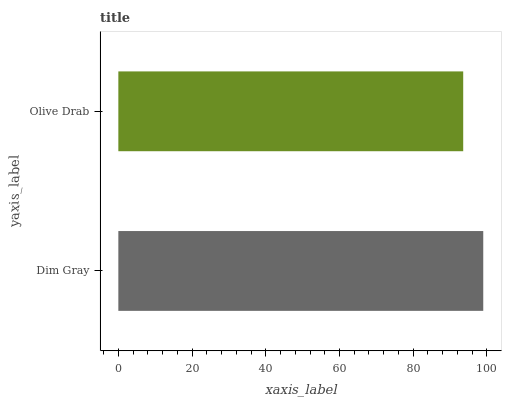Is Olive Drab the minimum?
Answer yes or no. Yes. Is Dim Gray the maximum?
Answer yes or no. Yes. Is Olive Drab the maximum?
Answer yes or no. No. Is Dim Gray greater than Olive Drab?
Answer yes or no. Yes. Is Olive Drab less than Dim Gray?
Answer yes or no. Yes. Is Olive Drab greater than Dim Gray?
Answer yes or no. No. Is Dim Gray less than Olive Drab?
Answer yes or no. No. Is Dim Gray the high median?
Answer yes or no. Yes. Is Olive Drab the low median?
Answer yes or no. Yes. Is Olive Drab the high median?
Answer yes or no. No. Is Dim Gray the low median?
Answer yes or no. No. 